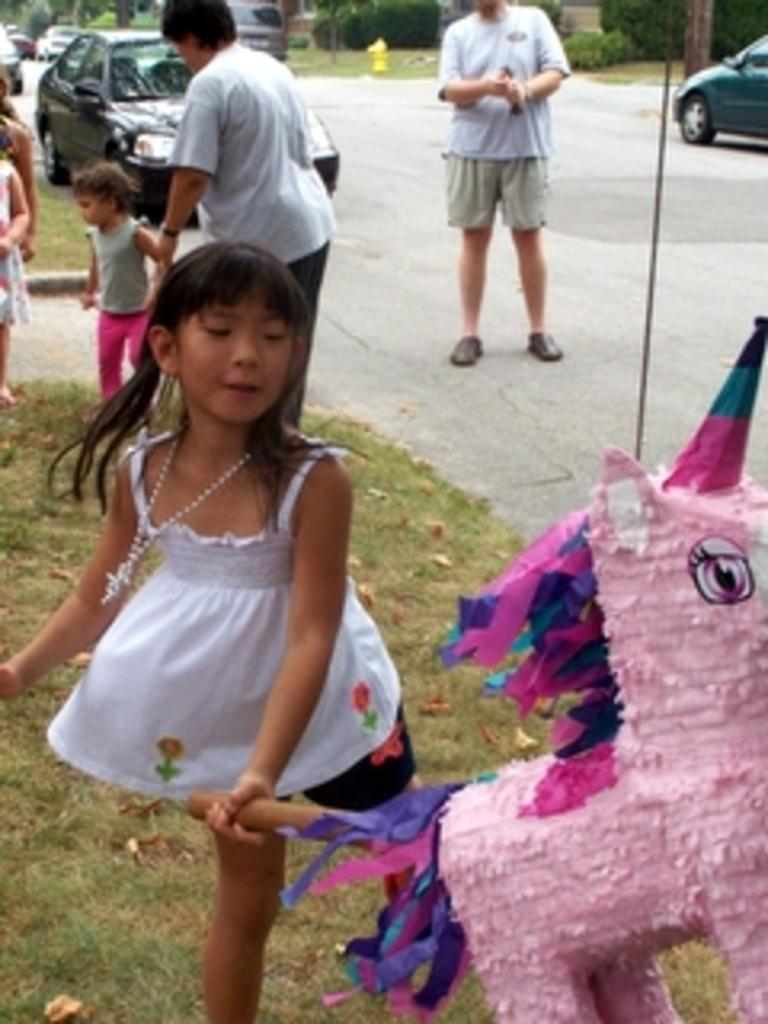What are the people in the image doing? The people in the image are standing on the ground. What activity is the child engaged in? The child is playing with a toy in the image. What can be seen in the background of the image? Motor vehicles are present on the road, and trees and shrubs are visible in the background. What type of clam is being used as a toy by the child in the image? There is no clam present in the image; the child is playing with a toy that is not specified. Can you tell me how many kittens are visible in the image? There are no kittens visible in the image. 